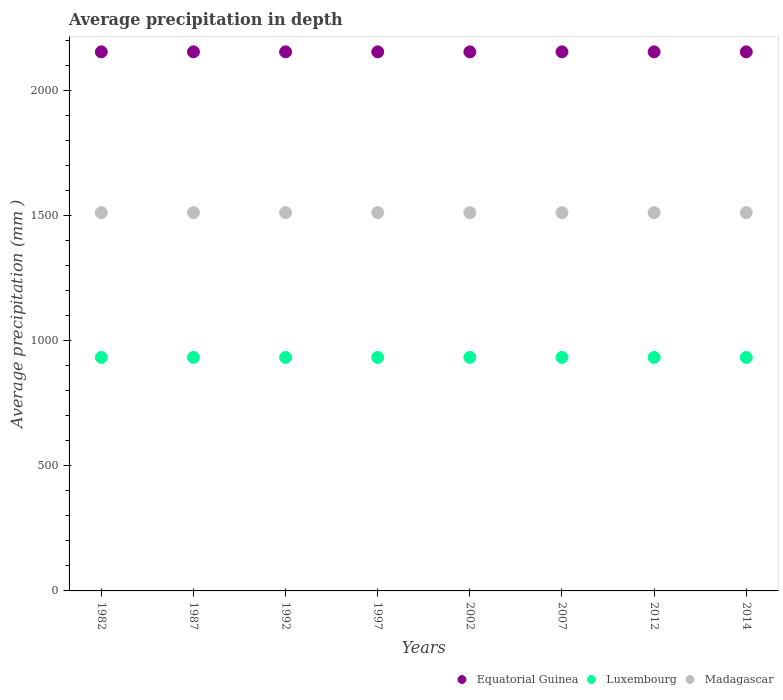What is the average precipitation in Luxembourg in 2014?
Your answer should be very brief. 934. Across all years, what is the maximum average precipitation in Equatorial Guinea?
Your answer should be very brief. 2156. Across all years, what is the minimum average precipitation in Equatorial Guinea?
Provide a succinct answer. 2156. In which year was the average precipitation in Equatorial Guinea minimum?
Provide a short and direct response. 1982. What is the total average precipitation in Equatorial Guinea in the graph?
Provide a succinct answer. 1.72e+04. What is the difference between the average precipitation in Equatorial Guinea in 1982 and the average precipitation in Luxembourg in 1987?
Provide a succinct answer. 1222. What is the average average precipitation in Equatorial Guinea per year?
Provide a short and direct response. 2156. In the year 1997, what is the difference between the average precipitation in Luxembourg and average precipitation in Equatorial Guinea?
Ensure brevity in your answer.  -1222. Is the sum of the average precipitation in Luxembourg in 1992 and 2007 greater than the maximum average precipitation in Equatorial Guinea across all years?
Offer a very short reply. No. Is it the case that in every year, the sum of the average precipitation in Luxembourg and average precipitation in Equatorial Guinea  is greater than the average precipitation in Madagascar?
Offer a very short reply. Yes. Does the average precipitation in Madagascar monotonically increase over the years?
Keep it short and to the point. No. Is the average precipitation in Madagascar strictly greater than the average precipitation in Equatorial Guinea over the years?
Ensure brevity in your answer.  No. How many dotlines are there?
Ensure brevity in your answer.  3. How many years are there in the graph?
Ensure brevity in your answer.  8. Does the graph contain any zero values?
Offer a terse response. No. Where does the legend appear in the graph?
Your answer should be very brief. Bottom right. How many legend labels are there?
Your answer should be compact. 3. What is the title of the graph?
Keep it short and to the point. Average precipitation in depth. Does "Iran" appear as one of the legend labels in the graph?
Your response must be concise. No. What is the label or title of the Y-axis?
Your answer should be very brief. Average precipitation (mm ). What is the Average precipitation (mm ) of Equatorial Guinea in 1982?
Provide a short and direct response. 2156. What is the Average precipitation (mm ) of Luxembourg in 1982?
Keep it short and to the point. 934. What is the Average precipitation (mm ) in Madagascar in 1982?
Make the answer very short. 1513. What is the Average precipitation (mm ) in Equatorial Guinea in 1987?
Offer a terse response. 2156. What is the Average precipitation (mm ) in Luxembourg in 1987?
Your answer should be compact. 934. What is the Average precipitation (mm ) in Madagascar in 1987?
Give a very brief answer. 1513. What is the Average precipitation (mm ) of Equatorial Guinea in 1992?
Offer a very short reply. 2156. What is the Average precipitation (mm ) of Luxembourg in 1992?
Ensure brevity in your answer.  934. What is the Average precipitation (mm ) in Madagascar in 1992?
Provide a succinct answer. 1513. What is the Average precipitation (mm ) of Equatorial Guinea in 1997?
Keep it short and to the point. 2156. What is the Average precipitation (mm ) of Luxembourg in 1997?
Keep it short and to the point. 934. What is the Average precipitation (mm ) of Madagascar in 1997?
Your answer should be very brief. 1513. What is the Average precipitation (mm ) of Equatorial Guinea in 2002?
Your answer should be compact. 2156. What is the Average precipitation (mm ) in Luxembourg in 2002?
Provide a succinct answer. 934. What is the Average precipitation (mm ) of Madagascar in 2002?
Make the answer very short. 1513. What is the Average precipitation (mm ) of Equatorial Guinea in 2007?
Provide a succinct answer. 2156. What is the Average precipitation (mm ) in Luxembourg in 2007?
Offer a terse response. 934. What is the Average precipitation (mm ) of Madagascar in 2007?
Your response must be concise. 1513. What is the Average precipitation (mm ) of Equatorial Guinea in 2012?
Provide a succinct answer. 2156. What is the Average precipitation (mm ) of Luxembourg in 2012?
Provide a succinct answer. 934. What is the Average precipitation (mm ) of Madagascar in 2012?
Give a very brief answer. 1513. What is the Average precipitation (mm ) of Equatorial Guinea in 2014?
Ensure brevity in your answer.  2156. What is the Average precipitation (mm ) in Luxembourg in 2014?
Your response must be concise. 934. What is the Average precipitation (mm ) in Madagascar in 2014?
Keep it short and to the point. 1513. Across all years, what is the maximum Average precipitation (mm ) of Equatorial Guinea?
Offer a terse response. 2156. Across all years, what is the maximum Average precipitation (mm ) of Luxembourg?
Provide a short and direct response. 934. Across all years, what is the maximum Average precipitation (mm ) in Madagascar?
Provide a short and direct response. 1513. Across all years, what is the minimum Average precipitation (mm ) in Equatorial Guinea?
Offer a terse response. 2156. Across all years, what is the minimum Average precipitation (mm ) of Luxembourg?
Your answer should be very brief. 934. Across all years, what is the minimum Average precipitation (mm ) of Madagascar?
Your answer should be very brief. 1513. What is the total Average precipitation (mm ) in Equatorial Guinea in the graph?
Provide a short and direct response. 1.72e+04. What is the total Average precipitation (mm ) in Luxembourg in the graph?
Make the answer very short. 7472. What is the total Average precipitation (mm ) of Madagascar in the graph?
Provide a succinct answer. 1.21e+04. What is the difference between the Average precipitation (mm ) in Luxembourg in 1982 and that in 1987?
Keep it short and to the point. 0. What is the difference between the Average precipitation (mm ) of Madagascar in 1982 and that in 1987?
Make the answer very short. 0. What is the difference between the Average precipitation (mm ) of Luxembourg in 1982 and that in 1992?
Provide a short and direct response. 0. What is the difference between the Average precipitation (mm ) in Madagascar in 1982 and that in 1992?
Offer a terse response. 0. What is the difference between the Average precipitation (mm ) in Equatorial Guinea in 1982 and that in 1997?
Ensure brevity in your answer.  0. What is the difference between the Average precipitation (mm ) in Luxembourg in 1982 and that in 1997?
Ensure brevity in your answer.  0. What is the difference between the Average precipitation (mm ) in Madagascar in 1982 and that in 1997?
Your answer should be compact. 0. What is the difference between the Average precipitation (mm ) in Madagascar in 1982 and that in 2002?
Make the answer very short. 0. What is the difference between the Average precipitation (mm ) of Equatorial Guinea in 1982 and that in 2007?
Provide a short and direct response. 0. What is the difference between the Average precipitation (mm ) of Luxembourg in 1982 and that in 2012?
Keep it short and to the point. 0. What is the difference between the Average precipitation (mm ) of Equatorial Guinea in 1982 and that in 2014?
Provide a short and direct response. 0. What is the difference between the Average precipitation (mm ) of Luxembourg in 1982 and that in 2014?
Your answer should be very brief. 0. What is the difference between the Average precipitation (mm ) of Madagascar in 1982 and that in 2014?
Your answer should be very brief. 0. What is the difference between the Average precipitation (mm ) of Equatorial Guinea in 1987 and that in 1992?
Your answer should be compact. 0. What is the difference between the Average precipitation (mm ) in Luxembourg in 1987 and that in 1992?
Keep it short and to the point. 0. What is the difference between the Average precipitation (mm ) of Luxembourg in 1987 and that in 1997?
Offer a very short reply. 0. What is the difference between the Average precipitation (mm ) of Madagascar in 1987 and that in 1997?
Keep it short and to the point. 0. What is the difference between the Average precipitation (mm ) in Equatorial Guinea in 1987 and that in 2002?
Give a very brief answer. 0. What is the difference between the Average precipitation (mm ) in Madagascar in 1987 and that in 2007?
Give a very brief answer. 0. What is the difference between the Average precipitation (mm ) in Luxembourg in 1987 and that in 2012?
Provide a succinct answer. 0. What is the difference between the Average precipitation (mm ) in Luxembourg in 1992 and that in 1997?
Provide a succinct answer. 0. What is the difference between the Average precipitation (mm ) in Madagascar in 1992 and that in 1997?
Keep it short and to the point. 0. What is the difference between the Average precipitation (mm ) of Luxembourg in 1992 and that in 2007?
Keep it short and to the point. 0. What is the difference between the Average precipitation (mm ) in Madagascar in 1992 and that in 2007?
Offer a terse response. 0. What is the difference between the Average precipitation (mm ) of Equatorial Guinea in 1992 and that in 2014?
Make the answer very short. 0. What is the difference between the Average precipitation (mm ) in Equatorial Guinea in 1997 and that in 2002?
Make the answer very short. 0. What is the difference between the Average precipitation (mm ) in Madagascar in 1997 and that in 2002?
Provide a short and direct response. 0. What is the difference between the Average precipitation (mm ) in Equatorial Guinea in 1997 and that in 2007?
Your response must be concise. 0. What is the difference between the Average precipitation (mm ) of Luxembourg in 1997 and that in 2012?
Provide a succinct answer. 0. What is the difference between the Average precipitation (mm ) in Madagascar in 1997 and that in 2014?
Make the answer very short. 0. What is the difference between the Average precipitation (mm ) of Luxembourg in 2002 and that in 2007?
Your response must be concise. 0. What is the difference between the Average precipitation (mm ) in Madagascar in 2002 and that in 2007?
Give a very brief answer. 0. What is the difference between the Average precipitation (mm ) of Equatorial Guinea in 2002 and that in 2012?
Provide a succinct answer. 0. What is the difference between the Average precipitation (mm ) in Luxembourg in 2002 and that in 2014?
Give a very brief answer. 0. What is the difference between the Average precipitation (mm ) in Madagascar in 2002 and that in 2014?
Ensure brevity in your answer.  0. What is the difference between the Average precipitation (mm ) of Luxembourg in 2007 and that in 2012?
Provide a succinct answer. 0. What is the difference between the Average precipitation (mm ) in Madagascar in 2007 and that in 2012?
Your response must be concise. 0. What is the difference between the Average precipitation (mm ) of Equatorial Guinea in 2007 and that in 2014?
Ensure brevity in your answer.  0. What is the difference between the Average precipitation (mm ) of Equatorial Guinea in 2012 and that in 2014?
Your answer should be compact. 0. What is the difference between the Average precipitation (mm ) in Madagascar in 2012 and that in 2014?
Make the answer very short. 0. What is the difference between the Average precipitation (mm ) of Equatorial Guinea in 1982 and the Average precipitation (mm ) of Luxembourg in 1987?
Your response must be concise. 1222. What is the difference between the Average precipitation (mm ) of Equatorial Guinea in 1982 and the Average precipitation (mm ) of Madagascar in 1987?
Make the answer very short. 643. What is the difference between the Average precipitation (mm ) of Luxembourg in 1982 and the Average precipitation (mm ) of Madagascar in 1987?
Provide a short and direct response. -579. What is the difference between the Average precipitation (mm ) of Equatorial Guinea in 1982 and the Average precipitation (mm ) of Luxembourg in 1992?
Your answer should be compact. 1222. What is the difference between the Average precipitation (mm ) in Equatorial Guinea in 1982 and the Average precipitation (mm ) in Madagascar in 1992?
Provide a short and direct response. 643. What is the difference between the Average precipitation (mm ) in Luxembourg in 1982 and the Average precipitation (mm ) in Madagascar in 1992?
Make the answer very short. -579. What is the difference between the Average precipitation (mm ) of Equatorial Guinea in 1982 and the Average precipitation (mm ) of Luxembourg in 1997?
Your answer should be very brief. 1222. What is the difference between the Average precipitation (mm ) in Equatorial Guinea in 1982 and the Average precipitation (mm ) in Madagascar in 1997?
Your response must be concise. 643. What is the difference between the Average precipitation (mm ) in Luxembourg in 1982 and the Average precipitation (mm ) in Madagascar in 1997?
Offer a terse response. -579. What is the difference between the Average precipitation (mm ) of Equatorial Guinea in 1982 and the Average precipitation (mm ) of Luxembourg in 2002?
Offer a very short reply. 1222. What is the difference between the Average precipitation (mm ) of Equatorial Guinea in 1982 and the Average precipitation (mm ) of Madagascar in 2002?
Offer a terse response. 643. What is the difference between the Average precipitation (mm ) in Luxembourg in 1982 and the Average precipitation (mm ) in Madagascar in 2002?
Ensure brevity in your answer.  -579. What is the difference between the Average precipitation (mm ) of Equatorial Guinea in 1982 and the Average precipitation (mm ) of Luxembourg in 2007?
Give a very brief answer. 1222. What is the difference between the Average precipitation (mm ) of Equatorial Guinea in 1982 and the Average precipitation (mm ) of Madagascar in 2007?
Keep it short and to the point. 643. What is the difference between the Average precipitation (mm ) of Luxembourg in 1982 and the Average precipitation (mm ) of Madagascar in 2007?
Ensure brevity in your answer.  -579. What is the difference between the Average precipitation (mm ) of Equatorial Guinea in 1982 and the Average precipitation (mm ) of Luxembourg in 2012?
Make the answer very short. 1222. What is the difference between the Average precipitation (mm ) in Equatorial Guinea in 1982 and the Average precipitation (mm ) in Madagascar in 2012?
Offer a terse response. 643. What is the difference between the Average precipitation (mm ) in Luxembourg in 1982 and the Average precipitation (mm ) in Madagascar in 2012?
Offer a terse response. -579. What is the difference between the Average precipitation (mm ) of Equatorial Guinea in 1982 and the Average precipitation (mm ) of Luxembourg in 2014?
Provide a succinct answer. 1222. What is the difference between the Average precipitation (mm ) of Equatorial Guinea in 1982 and the Average precipitation (mm ) of Madagascar in 2014?
Your answer should be very brief. 643. What is the difference between the Average precipitation (mm ) in Luxembourg in 1982 and the Average precipitation (mm ) in Madagascar in 2014?
Keep it short and to the point. -579. What is the difference between the Average precipitation (mm ) of Equatorial Guinea in 1987 and the Average precipitation (mm ) of Luxembourg in 1992?
Ensure brevity in your answer.  1222. What is the difference between the Average precipitation (mm ) in Equatorial Guinea in 1987 and the Average precipitation (mm ) in Madagascar in 1992?
Make the answer very short. 643. What is the difference between the Average precipitation (mm ) of Luxembourg in 1987 and the Average precipitation (mm ) of Madagascar in 1992?
Give a very brief answer. -579. What is the difference between the Average precipitation (mm ) in Equatorial Guinea in 1987 and the Average precipitation (mm ) in Luxembourg in 1997?
Make the answer very short. 1222. What is the difference between the Average precipitation (mm ) in Equatorial Guinea in 1987 and the Average precipitation (mm ) in Madagascar in 1997?
Offer a very short reply. 643. What is the difference between the Average precipitation (mm ) in Luxembourg in 1987 and the Average precipitation (mm ) in Madagascar in 1997?
Offer a very short reply. -579. What is the difference between the Average precipitation (mm ) of Equatorial Guinea in 1987 and the Average precipitation (mm ) of Luxembourg in 2002?
Give a very brief answer. 1222. What is the difference between the Average precipitation (mm ) of Equatorial Guinea in 1987 and the Average precipitation (mm ) of Madagascar in 2002?
Provide a short and direct response. 643. What is the difference between the Average precipitation (mm ) of Luxembourg in 1987 and the Average precipitation (mm ) of Madagascar in 2002?
Give a very brief answer. -579. What is the difference between the Average precipitation (mm ) in Equatorial Guinea in 1987 and the Average precipitation (mm ) in Luxembourg in 2007?
Provide a short and direct response. 1222. What is the difference between the Average precipitation (mm ) in Equatorial Guinea in 1987 and the Average precipitation (mm ) in Madagascar in 2007?
Offer a terse response. 643. What is the difference between the Average precipitation (mm ) of Luxembourg in 1987 and the Average precipitation (mm ) of Madagascar in 2007?
Offer a terse response. -579. What is the difference between the Average precipitation (mm ) of Equatorial Guinea in 1987 and the Average precipitation (mm ) of Luxembourg in 2012?
Offer a very short reply. 1222. What is the difference between the Average precipitation (mm ) of Equatorial Guinea in 1987 and the Average precipitation (mm ) of Madagascar in 2012?
Your response must be concise. 643. What is the difference between the Average precipitation (mm ) of Luxembourg in 1987 and the Average precipitation (mm ) of Madagascar in 2012?
Your answer should be very brief. -579. What is the difference between the Average precipitation (mm ) of Equatorial Guinea in 1987 and the Average precipitation (mm ) of Luxembourg in 2014?
Offer a terse response. 1222. What is the difference between the Average precipitation (mm ) of Equatorial Guinea in 1987 and the Average precipitation (mm ) of Madagascar in 2014?
Give a very brief answer. 643. What is the difference between the Average precipitation (mm ) of Luxembourg in 1987 and the Average precipitation (mm ) of Madagascar in 2014?
Offer a terse response. -579. What is the difference between the Average precipitation (mm ) in Equatorial Guinea in 1992 and the Average precipitation (mm ) in Luxembourg in 1997?
Make the answer very short. 1222. What is the difference between the Average precipitation (mm ) in Equatorial Guinea in 1992 and the Average precipitation (mm ) in Madagascar in 1997?
Offer a very short reply. 643. What is the difference between the Average precipitation (mm ) in Luxembourg in 1992 and the Average precipitation (mm ) in Madagascar in 1997?
Make the answer very short. -579. What is the difference between the Average precipitation (mm ) in Equatorial Guinea in 1992 and the Average precipitation (mm ) in Luxembourg in 2002?
Ensure brevity in your answer.  1222. What is the difference between the Average precipitation (mm ) of Equatorial Guinea in 1992 and the Average precipitation (mm ) of Madagascar in 2002?
Offer a terse response. 643. What is the difference between the Average precipitation (mm ) of Luxembourg in 1992 and the Average precipitation (mm ) of Madagascar in 2002?
Your response must be concise. -579. What is the difference between the Average precipitation (mm ) of Equatorial Guinea in 1992 and the Average precipitation (mm ) of Luxembourg in 2007?
Make the answer very short. 1222. What is the difference between the Average precipitation (mm ) of Equatorial Guinea in 1992 and the Average precipitation (mm ) of Madagascar in 2007?
Make the answer very short. 643. What is the difference between the Average precipitation (mm ) in Luxembourg in 1992 and the Average precipitation (mm ) in Madagascar in 2007?
Your answer should be compact. -579. What is the difference between the Average precipitation (mm ) in Equatorial Guinea in 1992 and the Average precipitation (mm ) in Luxembourg in 2012?
Keep it short and to the point. 1222. What is the difference between the Average precipitation (mm ) in Equatorial Guinea in 1992 and the Average precipitation (mm ) in Madagascar in 2012?
Keep it short and to the point. 643. What is the difference between the Average precipitation (mm ) in Luxembourg in 1992 and the Average precipitation (mm ) in Madagascar in 2012?
Your response must be concise. -579. What is the difference between the Average precipitation (mm ) in Equatorial Guinea in 1992 and the Average precipitation (mm ) in Luxembourg in 2014?
Your answer should be compact. 1222. What is the difference between the Average precipitation (mm ) in Equatorial Guinea in 1992 and the Average precipitation (mm ) in Madagascar in 2014?
Offer a terse response. 643. What is the difference between the Average precipitation (mm ) in Luxembourg in 1992 and the Average precipitation (mm ) in Madagascar in 2014?
Your answer should be compact. -579. What is the difference between the Average precipitation (mm ) in Equatorial Guinea in 1997 and the Average precipitation (mm ) in Luxembourg in 2002?
Your answer should be compact. 1222. What is the difference between the Average precipitation (mm ) of Equatorial Guinea in 1997 and the Average precipitation (mm ) of Madagascar in 2002?
Make the answer very short. 643. What is the difference between the Average precipitation (mm ) in Luxembourg in 1997 and the Average precipitation (mm ) in Madagascar in 2002?
Offer a terse response. -579. What is the difference between the Average precipitation (mm ) of Equatorial Guinea in 1997 and the Average precipitation (mm ) of Luxembourg in 2007?
Offer a very short reply. 1222. What is the difference between the Average precipitation (mm ) of Equatorial Guinea in 1997 and the Average precipitation (mm ) of Madagascar in 2007?
Your answer should be compact. 643. What is the difference between the Average precipitation (mm ) of Luxembourg in 1997 and the Average precipitation (mm ) of Madagascar in 2007?
Your response must be concise. -579. What is the difference between the Average precipitation (mm ) of Equatorial Guinea in 1997 and the Average precipitation (mm ) of Luxembourg in 2012?
Keep it short and to the point. 1222. What is the difference between the Average precipitation (mm ) in Equatorial Guinea in 1997 and the Average precipitation (mm ) in Madagascar in 2012?
Your answer should be very brief. 643. What is the difference between the Average precipitation (mm ) in Luxembourg in 1997 and the Average precipitation (mm ) in Madagascar in 2012?
Provide a succinct answer. -579. What is the difference between the Average precipitation (mm ) of Equatorial Guinea in 1997 and the Average precipitation (mm ) of Luxembourg in 2014?
Provide a short and direct response. 1222. What is the difference between the Average precipitation (mm ) of Equatorial Guinea in 1997 and the Average precipitation (mm ) of Madagascar in 2014?
Your answer should be compact. 643. What is the difference between the Average precipitation (mm ) of Luxembourg in 1997 and the Average precipitation (mm ) of Madagascar in 2014?
Your response must be concise. -579. What is the difference between the Average precipitation (mm ) of Equatorial Guinea in 2002 and the Average precipitation (mm ) of Luxembourg in 2007?
Your answer should be very brief. 1222. What is the difference between the Average precipitation (mm ) in Equatorial Guinea in 2002 and the Average precipitation (mm ) in Madagascar in 2007?
Offer a terse response. 643. What is the difference between the Average precipitation (mm ) of Luxembourg in 2002 and the Average precipitation (mm ) of Madagascar in 2007?
Offer a terse response. -579. What is the difference between the Average precipitation (mm ) of Equatorial Guinea in 2002 and the Average precipitation (mm ) of Luxembourg in 2012?
Ensure brevity in your answer.  1222. What is the difference between the Average precipitation (mm ) in Equatorial Guinea in 2002 and the Average precipitation (mm ) in Madagascar in 2012?
Your response must be concise. 643. What is the difference between the Average precipitation (mm ) of Luxembourg in 2002 and the Average precipitation (mm ) of Madagascar in 2012?
Offer a terse response. -579. What is the difference between the Average precipitation (mm ) of Equatorial Guinea in 2002 and the Average precipitation (mm ) of Luxembourg in 2014?
Provide a succinct answer. 1222. What is the difference between the Average precipitation (mm ) in Equatorial Guinea in 2002 and the Average precipitation (mm ) in Madagascar in 2014?
Your response must be concise. 643. What is the difference between the Average precipitation (mm ) in Luxembourg in 2002 and the Average precipitation (mm ) in Madagascar in 2014?
Your answer should be very brief. -579. What is the difference between the Average precipitation (mm ) of Equatorial Guinea in 2007 and the Average precipitation (mm ) of Luxembourg in 2012?
Your response must be concise. 1222. What is the difference between the Average precipitation (mm ) in Equatorial Guinea in 2007 and the Average precipitation (mm ) in Madagascar in 2012?
Make the answer very short. 643. What is the difference between the Average precipitation (mm ) in Luxembourg in 2007 and the Average precipitation (mm ) in Madagascar in 2012?
Give a very brief answer. -579. What is the difference between the Average precipitation (mm ) of Equatorial Guinea in 2007 and the Average precipitation (mm ) of Luxembourg in 2014?
Provide a short and direct response. 1222. What is the difference between the Average precipitation (mm ) of Equatorial Guinea in 2007 and the Average precipitation (mm ) of Madagascar in 2014?
Keep it short and to the point. 643. What is the difference between the Average precipitation (mm ) of Luxembourg in 2007 and the Average precipitation (mm ) of Madagascar in 2014?
Offer a very short reply. -579. What is the difference between the Average precipitation (mm ) of Equatorial Guinea in 2012 and the Average precipitation (mm ) of Luxembourg in 2014?
Keep it short and to the point. 1222. What is the difference between the Average precipitation (mm ) of Equatorial Guinea in 2012 and the Average precipitation (mm ) of Madagascar in 2014?
Give a very brief answer. 643. What is the difference between the Average precipitation (mm ) in Luxembourg in 2012 and the Average precipitation (mm ) in Madagascar in 2014?
Provide a short and direct response. -579. What is the average Average precipitation (mm ) in Equatorial Guinea per year?
Make the answer very short. 2156. What is the average Average precipitation (mm ) in Luxembourg per year?
Give a very brief answer. 934. What is the average Average precipitation (mm ) of Madagascar per year?
Offer a very short reply. 1513. In the year 1982, what is the difference between the Average precipitation (mm ) of Equatorial Guinea and Average precipitation (mm ) of Luxembourg?
Keep it short and to the point. 1222. In the year 1982, what is the difference between the Average precipitation (mm ) of Equatorial Guinea and Average precipitation (mm ) of Madagascar?
Make the answer very short. 643. In the year 1982, what is the difference between the Average precipitation (mm ) of Luxembourg and Average precipitation (mm ) of Madagascar?
Keep it short and to the point. -579. In the year 1987, what is the difference between the Average precipitation (mm ) of Equatorial Guinea and Average precipitation (mm ) of Luxembourg?
Make the answer very short. 1222. In the year 1987, what is the difference between the Average precipitation (mm ) of Equatorial Guinea and Average precipitation (mm ) of Madagascar?
Ensure brevity in your answer.  643. In the year 1987, what is the difference between the Average precipitation (mm ) in Luxembourg and Average precipitation (mm ) in Madagascar?
Your answer should be very brief. -579. In the year 1992, what is the difference between the Average precipitation (mm ) in Equatorial Guinea and Average precipitation (mm ) in Luxembourg?
Offer a terse response. 1222. In the year 1992, what is the difference between the Average precipitation (mm ) in Equatorial Guinea and Average precipitation (mm ) in Madagascar?
Offer a terse response. 643. In the year 1992, what is the difference between the Average precipitation (mm ) in Luxembourg and Average precipitation (mm ) in Madagascar?
Keep it short and to the point. -579. In the year 1997, what is the difference between the Average precipitation (mm ) in Equatorial Guinea and Average precipitation (mm ) in Luxembourg?
Your answer should be compact. 1222. In the year 1997, what is the difference between the Average precipitation (mm ) in Equatorial Guinea and Average precipitation (mm ) in Madagascar?
Keep it short and to the point. 643. In the year 1997, what is the difference between the Average precipitation (mm ) in Luxembourg and Average precipitation (mm ) in Madagascar?
Provide a short and direct response. -579. In the year 2002, what is the difference between the Average precipitation (mm ) of Equatorial Guinea and Average precipitation (mm ) of Luxembourg?
Your answer should be very brief. 1222. In the year 2002, what is the difference between the Average precipitation (mm ) in Equatorial Guinea and Average precipitation (mm ) in Madagascar?
Make the answer very short. 643. In the year 2002, what is the difference between the Average precipitation (mm ) of Luxembourg and Average precipitation (mm ) of Madagascar?
Keep it short and to the point. -579. In the year 2007, what is the difference between the Average precipitation (mm ) of Equatorial Guinea and Average precipitation (mm ) of Luxembourg?
Make the answer very short. 1222. In the year 2007, what is the difference between the Average precipitation (mm ) of Equatorial Guinea and Average precipitation (mm ) of Madagascar?
Make the answer very short. 643. In the year 2007, what is the difference between the Average precipitation (mm ) of Luxembourg and Average precipitation (mm ) of Madagascar?
Give a very brief answer. -579. In the year 2012, what is the difference between the Average precipitation (mm ) of Equatorial Guinea and Average precipitation (mm ) of Luxembourg?
Your response must be concise. 1222. In the year 2012, what is the difference between the Average precipitation (mm ) of Equatorial Guinea and Average precipitation (mm ) of Madagascar?
Your answer should be very brief. 643. In the year 2012, what is the difference between the Average precipitation (mm ) in Luxembourg and Average precipitation (mm ) in Madagascar?
Offer a terse response. -579. In the year 2014, what is the difference between the Average precipitation (mm ) of Equatorial Guinea and Average precipitation (mm ) of Luxembourg?
Your answer should be very brief. 1222. In the year 2014, what is the difference between the Average precipitation (mm ) in Equatorial Guinea and Average precipitation (mm ) in Madagascar?
Your answer should be very brief. 643. In the year 2014, what is the difference between the Average precipitation (mm ) of Luxembourg and Average precipitation (mm ) of Madagascar?
Ensure brevity in your answer.  -579. What is the ratio of the Average precipitation (mm ) in Luxembourg in 1982 to that in 1987?
Provide a short and direct response. 1. What is the ratio of the Average precipitation (mm ) of Madagascar in 1982 to that in 1992?
Provide a succinct answer. 1. What is the ratio of the Average precipitation (mm ) of Luxembourg in 1982 to that in 1997?
Your answer should be compact. 1. What is the ratio of the Average precipitation (mm ) of Madagascar in 1982 to that in 1997?
Your answer should be compact. 1. What is the ratio of the Average precipitation (mm ) in Luxembourg in 1982 to that in 2002?
Your answer should be very brief. 1. What is the ratio of the Average precipitation (mm ) in Madagascar in 1982 to that in 2002?
Your answer should be compact. 1. What is the ratio of the Average precipitation (mm ) of Luxembourg in 1982 to that in 2012?
Provide a succinct answer. 1. What is the ratio of the Average precipitation (mm ) of Madagascar in 1982 to that in 2012?
Ensure brevity in your answer.  1. What is the ratio of the Average precipitation (mm ) in Equatorial Guinea in 1982 to that in 2014?
Keep it short and to the point. 1. What is the ratio of the Average precipitation (mm ) in Luxembourg in 1982 to that in 2014?
Provide a succinct answer. 1. What is the ratio of the Average precipitation (mm ) of Madagascar in 1982 to that in 2014?
Offer a very short reply. 1. What is the ratio of the Average precipitation (mm ) in Madagascar in 1987 to that in 1997?
Provide a succinct answer. 1. What is the ratio of the Average precipitation (mm ) in Madagascar in 1987 to that in 2002?
Keep it short and to the point. 1. What is the ratio of the Average precipitation (mm ) of Equatorial Guinea in 1987 to that in 2007?
Provide a short and direct response. 1. What is the ratio of the Average precipitation (mm ) in Madagascar in 1987 to that in 2007?
Your answer should be compact. 1. What is the ratio of the Average precipitation (mm ) of Equatorial Guinea in 1987 to that in 2012?
Give a very brief answer. 1. What is the ratio of the Average precipitation (mm ) of Madagascar in 1987 to that in 2012?
Keep it short and to the point. 1. What is the ratio of the Average precipitation (mm ) of Luxembourg in 1987 to that in 2014?
Make the answer very short. 1. What is the ratio of the Average precipitation (mm ) in Equatorial Guinea in 1992 to that in 1997?
Give a very brief answer. 1. What is the ratio of the Average precipitation (mm ) of Luxembourg in 1992 to that in 1997?
Ensure brevity in your answer.  1. What is the ratio of the Average precipitation (mm ) in Equatorial Guinea in 1992 to that in 2002?
Give a very brief answer. 1. What is the ratio of the Average precipitation (mm ) in Equatorial Guinea in 1992 to that in 2007?
Offer a very short reply. 1. What is the ratio of the Average precipitation (mm ) in Madagascar in 1992 to that in 2014?
Keep it short and to the point. 1. What is the ratio of the Average precipitation (mm ) of Equatorial Guinea in 1997 to that in 2002?
Provide a short and direct response. 1. What is the ratio of the Average precipitation (mm ) in Madagascar in 1997 to that in 2002?
Provide a short and direct response. 1. What is the ratio of the Average precipitation (mm ) of Equatorial Guinea in 1997 to that in 2007?
Provide a short and direct response. 1. What is the ratio of the Average precipitation (mm ) in Luxembourg in 1997 to that in 2007?
Offer a very short reply. 1. What is the ratio of the Average precipitation (mm ) of Madagascar in 1997 to that in 2007?
Your response must be concise. 1. What is the ratio of the Average precipitation (mm ) of Equatorial Guinea in 1997 to that in 2012?
Provide a short and direct response. 1. What is the ratio of the Average precipitation (mm ) in Madagascar in 1997 to that in 2012?
Offer a terse response. 1. What is the ratio of the Average precipitation (mm ) of Equatorial Guinea in 1997 to that in 2014?
Make the answer very short. 1. What is the ratio of the Average precipitation (mm ) of Luxembourg in 1997 to that in 2014?
Your response must be concise. 1. What is the ratio of the Average precipitation (mm ) of Equatorial Guinea in 2002 to that in 2007?
Make the answer very short. 1. What is the ratio of the Average precipitation (mm ) in Luxembourg in 2002 to that in 2007?
Ensure brevity in your answer.  1. What is the ratio of the Average precipitation (mm ) of Madagascar in 2002 to that in 2007?
Your response must be concise. 1. What is the ratio of the Average precipitation (mm ) in Luxembourg in 2002 to that in 2012?
Your answer should be very brief. 1. What is the ratio of the Average precipitation (mm ) in Madagascar in 2002 to that in 2012?
Your answer should be compact. 1. What is the ratio of the Average precipitation (mm ) of Luxembourg in 2002 to that in 2014?
Provide a succinct answer. 1. What is the ratio of the Average precipitation (mm ) of Luxembourg in 2007 to that in 2012?
Make the answer very short. 1. What is the ratio of the Average precipitation (mm ) of Madagascar in 2007 to that in 2012?
Keep it short and to the point. 1. What is the ratio of the Average precipitation (mm ) in Luxembourg in 2007 to that in 2014?
Your answer should be compact. 1. What is the ratio of the Average precipitation (mm ) of Madagascar in 2012 to that in 2014?
Keep it short and to the point. 1. What is the difference between the highest and the second highest Average precipitation (mm ) of Madagascar?
Give a very brief answer. 0. What is the difference between the highest and the lowest Average precipitation (mm ) of Equatorial Guinea?
Provide a succinct answer. 0. What is the difference between the highest and the lowest Average precipitation (mm ) in Luxembourg?
Give a very brief answer. 0. What is the difference between the highest and the lowest Average precipitation (mm ) of Madagascar?
Provide a short and direct response. 0. 